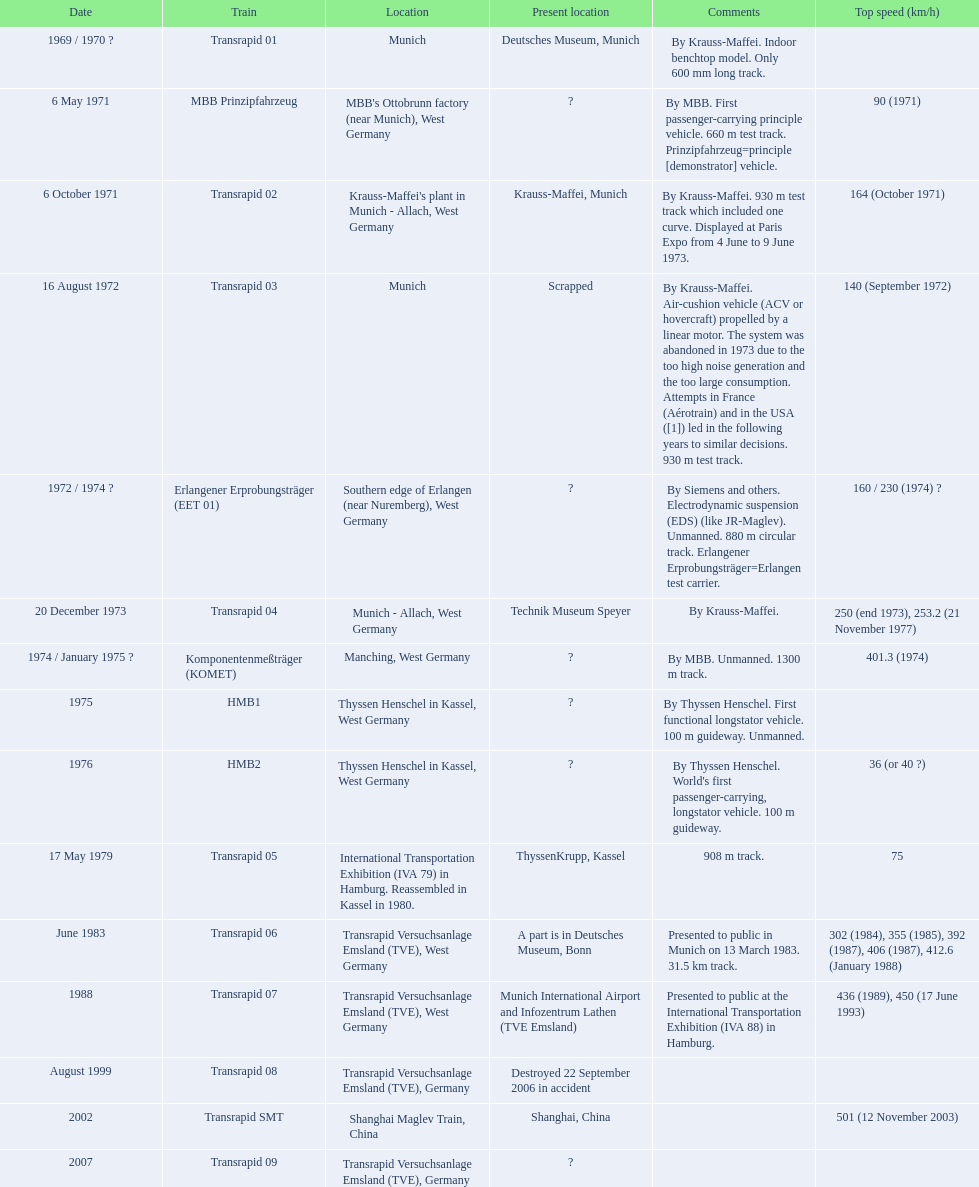Which trains display their top speed? MBB Prinzipfahrzeug, Transrapid 02, Transrapid 03, Erlangener Erprobungsträger (EET 01), Transrapid 04, Komponentenmeßträger (KOMET), HMB2, Transrapid 05, Transrapid 06, Transrapid 07, Transrapid SMT. Which of these have munich listed as a location? MBB Prinzipfahrzeug, Transrapid 02, Transrapid 03. From these, which ones have a confirmed present location? Transrapid 02, Transrapid 03. Which of these are not in service anymore? Transrapid 03. 